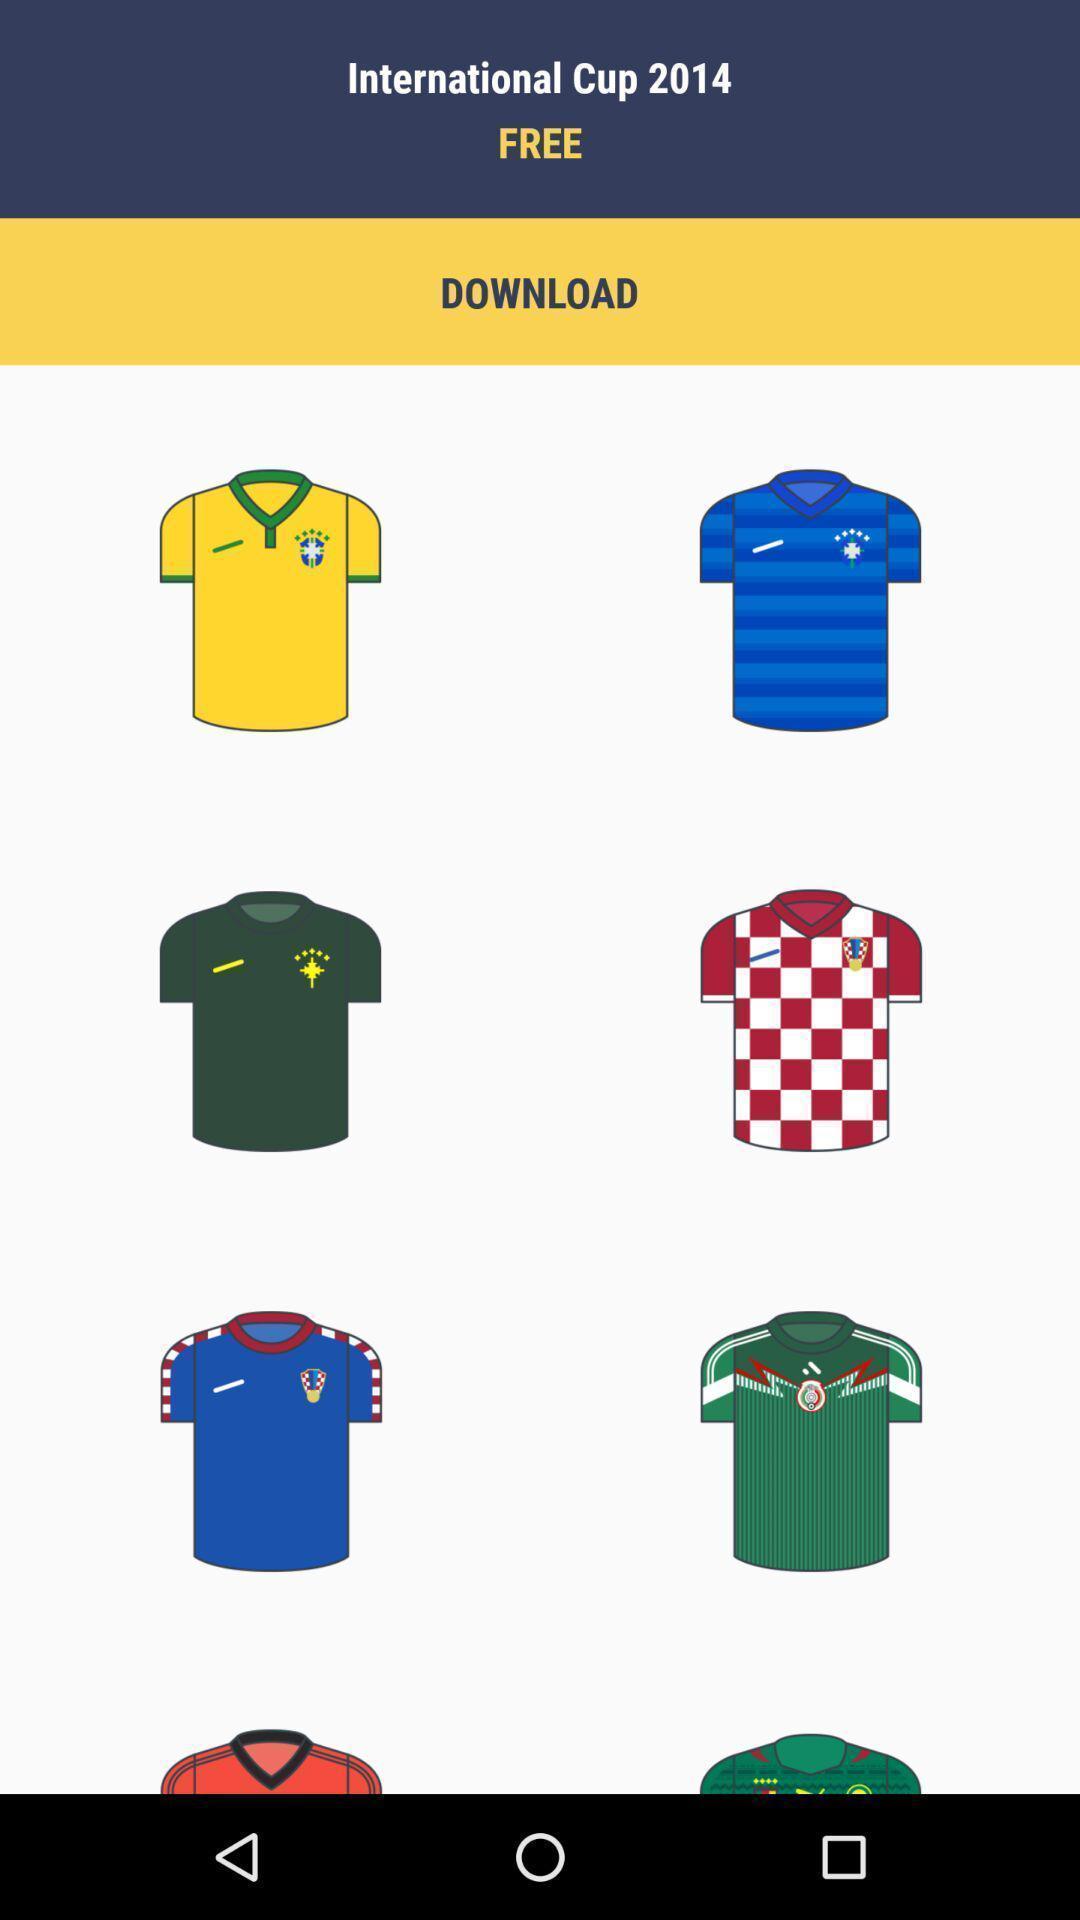Please provide a description for this image. Showing download screen of t-shirts of football. 